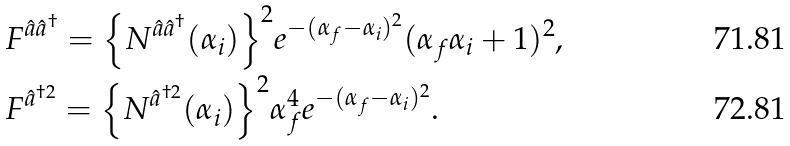Convert formula to latex. <formula><loc_0><loc_0><loc_500><loc_500>& { F ^ { \hat { a } \hat { a } ^ { \dag } } } = { \left \{ N ^ { \hat { a } \hat { a } ^ { \dag } } ( { \alpha _ { i } } ) \right \} ^ { 2 } } { e ^ { - ( \alpha _ { f } - { \alpha _ { i } } ) ^ { 2 } } ( \alpha _ { f } { \alpha _ { i } } + 1 ) ^ { 2 } } , \\ & { F ^ { \hat { a } ^ { \dag 2 } } } = { \left \{ N ^ { \hat { a } ^ { \dag 2 } } ( { \alpha _ { i } } ) \right \} ^ { 2 } } { \alpha _ { f } ^ { 4 } e ^ { - ( { \alpha _ { f } } - \alpha _ { i } ) ^ { 2 } } } .</formula> 